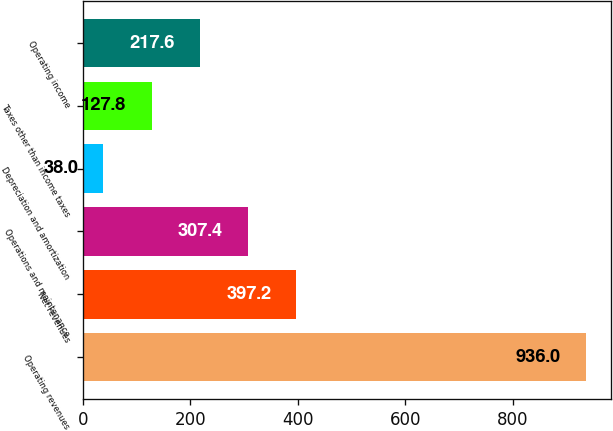<chart> <loc_0><loc_0><loc_500><loc_500><bar_chart><fcel>Operating revenues<fcel>Net revenues<fcel>Operations and maintenance<fcel>Depreciation and amortization<fcel>Taxes other than income taxes<fcel>Operating income<nl><fcel>936<fcel>397.2<fcel>307.4<fcel>38<fcel>127.8<fcel>217.6<nl></chart> 